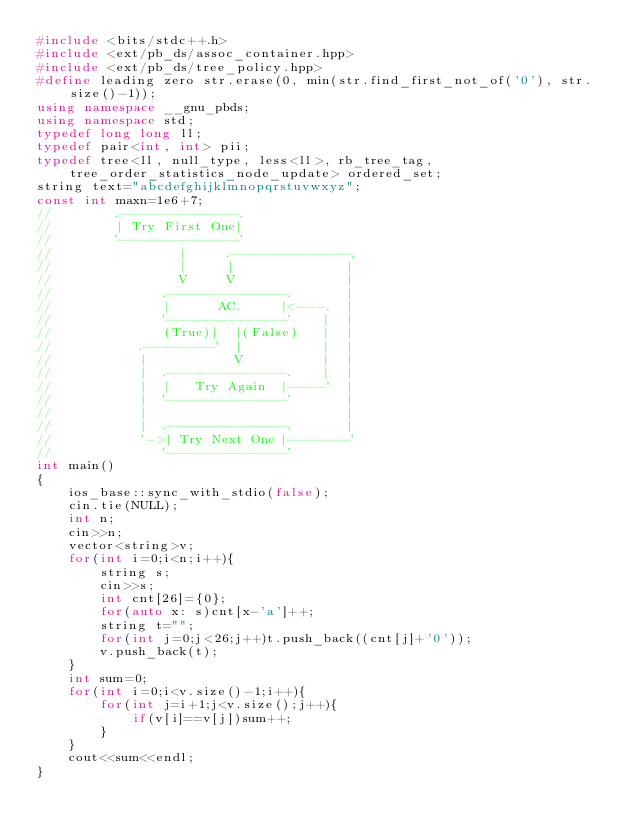Convert code to text. <code><loc_0><loc_0><loc_500><loc_500><_C++_>#include <bits/stdc++.h>
#include <ext/pb_ds/assoc_container.hpp>
#include <ext/pb_ds/tree_policy.hpp>
#define leading zero str.erase(0, min(str.find_first_not_of('0'), str.size()-1));
using namespace __gnu_pbds;
using namespace std;
typedef long long ll;
typedef pair<int, int> pii;
typedef tree<ll, null_type, less<ll>, rb_tree_tag, tree_order_statistics_node_update> ordered_set;
string text="abcdefghijklmnopqrstuvwxyz";
const int maxn=1e6+7;
//        .--------------.
//        | Try First One|
//        '--------------'
//                |     .--------------.
//                |     |              |
//                V     V              |
//              .--------------.       |
//              |      AC.     |<---.  |
//              '--------------'    |  |
//              (True)|  |(False)   |  |
//           .--------'  |          |  |
//           |           V          |  |
//           |  .--------------.    |  |
//           |  |   Try Again  |----'  |
//           |  '--------------'       |
//           |                         |
//           |  .--------------.       |
//           '->| Try Next One |-------'
//              '--------------'
int main()
{
    ios_base::sync_with_stdio(false);
    cin.tie(NULL);
    int n;
    cin>>n;
    vector<string>v;
    for(int i=0;i<n;i++){
        string s;
        cin>>s;
        int cnt[26]={0};
        for(auto x: s)cnt[x-'a']++;
        string t="";
        for(int j=0;j<26;j++)t.push_back((cnt[j]+'0'));
        v.push_back(t);
    }
    int sum=0;
    for(int i=0;i<v.size()-1;i++){
        for(int j=i+1;j<v.size();j++){
            if(v[i]==v[j])sum++;
        }
    }
    cout<<sum<<endl;
}
</code> 